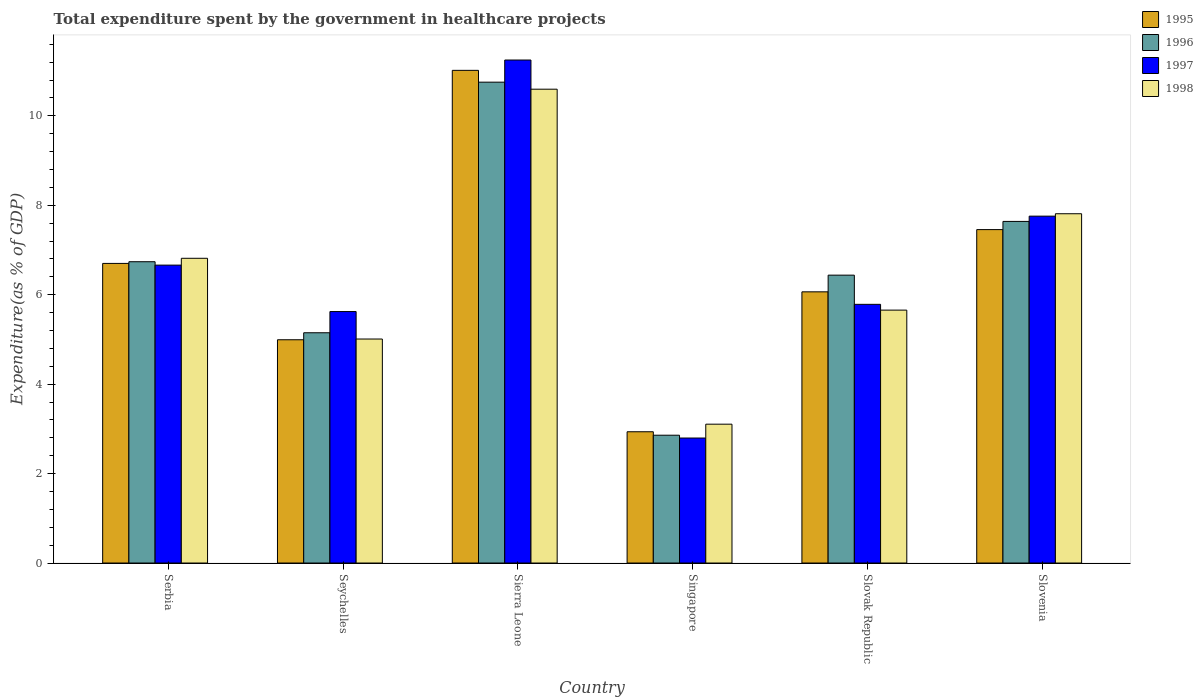How many different coloured bars are there?
Ensure brevity in your answer.  4. How many groups of bars are there?
Ensure brevity in your answer.  6. Are the number of bars on each tick of the X-axis equal?
Your answer should be very brief. Yes. How many bars are there on the 3rd tick from the left?
Offer a terse response. 4. How many bars are there on the 5th tick from the right?
Provide a succinct answer. 4. What is the label of the 4th group of bars from the left?
Your answer should be very brief. Singapore. In how many cases, is the number of bars for a given country not equal to the number of legend labels?
Your answer should be compact. 0. What is the total expenditure spent by the government in healthcare projects in 1997 in Slovenia?
Offer a very short reply. 7.76. Across all countries, what is the maximum total expenditure spent by the government in healthcare projects in 1998?
Provide a short and direct response. 10.59. Across all countries, what is the minimum total expenditure spent by the government in healthcare projects in 1998?
Your answer should be very brief. 3.1. In which country was the total expenditure spent by the government in healthcare projects in 1997 maximum?
Provide a succinct answer. Sierra Leone. In which country was the total expenditure spent by the government in healthcare projects in 1997 minimum?
Ensure brevity in your answer.  Singapore. What is the total total expenditure spent by the government in healthcare projects in 1998 in the graph?
Your answer should be very brief. 38.99. What is the difference between the total expenditure spent by the government in healthcare projects in 1997 in Serbia and that in Slovenia?
Give a very brief answer. -1.09. What is the difference between the total expenditure spent by the government in healthcare projects in 1996 in Sierra Leone and the total expenditure spent by the government in healthcare projects in 1997 in Slovak Republic?
Keep it short and to the point. 4.97. What is the average total expenditure spent by the government in healthcare projects in 1998 per country?
Ensure brevity in your answer.  6.5. What is the difference between the total expenditure spent by the government in healthcare projects of/in 1995 and total expenditure spent by the government in healthcare projects of/in 1997 in Serbia?
Offer a very short reply. 0.04. In how many countries, is the total expenditure spent by the government in healthcare projects in 1996 greater than 8.8 %?
Offer a terse response. 1. What is the ratio of the total expenditure spent by the government in healthcare projects in 1997 in Seychelles to that in Slovak Republic?
Keep it short and to the point. 0.97. What is the difference between the highest and the second highest total expenditure spent by the government in healthcare projects in 1996?
Your answer should be compact. 4.02. What is the difference between the highest and the lowest total expenditure spent by the government in healthcare projects in 1995?
Offer a very short reply. 8.08. In how many countries, is the total expenditure spent by the government in healthcare projects in 1995 greater than the average total expenditure spent by the government in healthcare projects in 1995 taken over all countries?
Your answer should be compact. 3. Is the sum of the total expenditure spent by the government in healthcare projects in 1998 in Seychelles and Slovenia greater than the maximum total expenditure spent by the government in healthcare projects in 1995 across all countries?
Offer a terse response. Yes. Is it the case that in every country, the sum of the total expenditure spent by the government in healthcare projects in 1998 and total expenditure spent by the government in healthcare projects in 1995 is greater than the sum of total expenditure spent by the government in healthcare projects in 1997 and total expenditure spent by the government in healthcare projects in 1996?
Offer a very short reply. No. How many bars are there?
Offer a terse response. 24. Does the graph contain any zero values?
Your answer should be compact. No. Does the graph contain grids?
Your answer should be compact. No. Where does the legend appear in the graph?
Offer a very short reply. Top right. How many legend labels are there?
Ensure brevity in your answer.  4. How are the legend labels stacked?
Provide a succinct answer. Vertical. What is the title of the graph?
Give a very brief answer. Total expenditure spent by the government in healthcare projects. Does "1961" appear as one of the legend labels in the graph?
Your answer should be very brief. No. What is the label or title of the X-axis?
Offer a very short reply. Country. What is the label or title of the Y-axis?
Provide a short and direct response. Expenditure(as % of GDP). What is the Expenditure(as % of GDP) in 1995 in Serbia?
Offer a terse response. 6.7. What is the Expenditure(as % of GDP) of 1996 in Serbia?
Keep it short and to the point. 6.74. What is the Expenditure(as % of GDP) of 1997 in Serbia?
Provide a short and direct response. 6.66. What is the Expenditure(as % of GDP) in 1998 in Serbia?
Give a very brief answer. 6.81. What is the Expenditure(as % of GDP) in 1995 in Seychelles?
Make the answer very short. 4.99. What is the Expenditure(as % of GDP) in 1996 in Seychelles?
Provide a succinct answer. 5.15. What is the Expenditure(as % of GDP) of 1997 in Seychelles?
Your response must be concise. 5.62. What is the Expenditure(as % of GDP) of 1998 in Seychelles?
Offer a terse response. 5.01. What is the Expenditure(as % of GDP) of 1995 in Sierra Leone?
Provide a short and direct response. 11.02. What is the Expenditure(as % of GDP) in 1996 in Sierra Leone?
Provide a short and direct response. 10.75. What is the Expenditure(as % of GDP) of 1997 in Sierra Leone?
Ensure brevity in your answer.  11.25. What is the Expenditure(as % of GDP) in 1998 in Sierra Leone?
Offer a very short reply. 10.59. What is the Expenditure(as % of GDP) of 1995 in Singapore?
Your answer should be compact. 2.94. What is the Expenditure(as % of GDP) in 1996 in Singapore?
Make the answer very short. 2.86. What is the Expenditure(as % of GDP) of 1997 in Singapore?
Provide a short and direct response. 2.8. What is the Expenditure(as % of GDP) of 1998 in Singapore?
Give a very brief answer. 3.1. What is the Expenditure(as % of GDP) of 1995 in Slovak Republic?
Your response must be concise. 6.06. What is the Expenditure(as % of GDP) in 1996 in Slovak Republic?
Your answer should be compact. 6.44. What is the Expenditure(as % of GDP) in 1997 in Slovak Republic?
Provide a succinct answer. 5.78. What is the Expenditure(as % of GDP) in 1998 in Slovak Republic?
Provide a succinct answer. 5.66. What is the Expenditure(as % of GDP) in 1995 in Slovenia?
Provide a succinct answer. 7.46. What is the Expenditure(as % of GDP) of 1996 in Slovenia?
Provide a succinct answer. 7.64. What is the Expenditure(as % of GDP) in 1997 in Slovenia?
Make the answer very short. 7.76. What is the Expenditure(as % of GDP) in 1998 in Slovenia?
Provide a succinct answer. 7.81. Across all countries, what is the maximum Expenditure(as % of GDP) of 1995?
Provide a short and direct response. 11.02. Across all countries, what is the maximum Expenditure(as % of GDP) in 1996?
Ensure brevity in your answer.  10.75. Across all countries, what is the maximum Expenditure(as % of GDP) of 1997?
Your answer should be very brief. 11.25. Across all countries, what is the maximum Expenditure(as % of GDP) of 1998?
Your answer should be very brief. 10.59. Across all countries, what is the minimum Expenditure(as % of GDP) of 1995?
Provide a short and direct response. 2.94. Across all countries, what is the minimum Expenditure(as % of GDP) in 1996?
Ensure brevity in your answer.  2.86. Across all countries, what is the minimum Expenditure(as % of GDP) in 1997?
Ensure brevity in your answer.  2.8. Across all countries, what is the minimum Expenditure(as % of GDP) in 1998?
Offer a very short reply. 3.1. What is the total Expenditure(as % of GDP) in 1995 in the graph?
Your answer should be compact. 39.16. What is the total Expenditure(as % of GDP) in 1996 in the graph?
Make the answer very short. 39.57. What is the total Expenditure(as % of GDP) in 1997 in the graph?
Provide a succinct answer. 39.87. What is the total Expenditure(as % of GDP) of 1998 in the graph?
Your answer should be very brief. 38.99. What is the difference between the Expenditure(as % of GDP) of 1995 in Serbia and that in Seychelles?
Ensure brevity in your answer.  1.71. What is the difference between the Expenditure(as % of GDP) in 1996 in Serbia and that in Seychelles?
Your answer should be compact. 1.59. What is the difference between the Expenditure(as % of GDP) of 1997 in Serbia and that in Seychelles?
Make the answer very short. 1.04. What is the difference between the Expenditure(as % of GDP) of 1998 in Serbia and that in Seychelles?
Your response must be concise. 1.81. What is the difference between the Expenditure(as % of GDP) in 1995 in Serbia and that in Sierra Leone?
Your answer should be compact. -4.32. What is the difference between the Expenditure(as % of GDP) in 1996 in Serbia and that in Sierra Leone?
Provide a succinct answer. -4.02. What is the difference between the Expenditure(as % of GDP) of 1997 in Serbia and that in Sierra Leone?
Ensure brevity in your answer.  -4.59. What is the difference between the Expenditure(as % of GDP) in 1998 in Serbia and that in Sierra Leone?
Your answer should be compact. -3.78. What is the difference between the Expenditure(as % of GDP) of 1995 in Serbia and that in Singapore?
Provide a short and direct response. 3.76. What is the difference between the Expenditure(as % of GDP) of 1996 in Serbia and that in Singapore?
Ensure brevity in your answer.  3.88. What is the difference between the Expenditure(as % of GDP) in 1997 in Serbia and that in Singapore?
Provide a succinct answer. 3.87. What is the difference between the Expenditure(as % of GDP) in 1998 in Serbia and that in Singapore?
Provide a succinct answer. 3.71. What is the difference between the Expenditure(as % of GDP) of 1995 in Serbia and that in Slovak Republic?
Keep it short and to the point. 0.64. What is the difference between the Expenditure(as % of GDP) in 1996 in Serbia and that in Slovak Republic?
Your response must be concise. 0.3. What is the difference between the Expenditure(as % of GDP) of 1997 in Serbia and that in Slovak Republic?
Your answer should be very brief. 0.88. What is the difference between the Expenditure(as % of GDP) of 1998 in Serbia and that in Slovak Republic?
Give a very brief answer. 1.16. What is the difference between the Expenditure(as % of GDP) of 1995 in Serbia and that in Slovenia?
Provide a short and direct response. -0.76. What is the difference between the Expenditure(as % of GDP) in 1996 in Serbia and that in Slovenia?
Make the answer very short. -0.9. What is the difference between the Expenditure(as % of GDP) in 1997 in Serbia and that in Slovenia?
Your answer should be very brief. -1.09. What is the difference between the Expenditure(as % of GDP) in 1998 in Serbia and that in Slovenia?
Offer a very short reply. -1. What is the difference between the Expenditure(as % of GDP) in 1995 in Seychelles and that in Sierra Leone?
Keep it short and to the point. -6.02. What is the difference between the Expenditure(as % of GDP) in 1996 in Seychelles and that in Sierra Leone?
Make the answer very short. -5.6. What is the difference between the Expenditure(as % of GDP) in 1997 in Seychelles and that in Sierra Leone?
Offer a very short reply. -5.62. What is the difference between the Expenditure(as % of GDP) of 1998 in Seychelles and that in Sierra Leone?
Your answer should be very brief. -5.59. What is the difference between the Expenditure(as % of GDP) in 1995 in Seychelles and that in Singapore?
Offer a very short reply. 2.06. What is the difference between the Expenditure(as % of GDP) in 1996 in Seychelles and that in Singapore?
Make the answer very short. 2.29. What is the difference between the Expenditure(as % of GDP) in 1997 in Seychelles and that in Singapore?
Your answer should be compact. 2.83. What is the difference between the Expenditure(as % of GDP) in 1998 in Seychelles and that in Singapore?
Your answer should be compact. 1.9. What is the difference between the Expenditure(as % of GDP) of 1995 in Seychelles and that in Slovak Republic?
Offer a terse response. -1.07. What is the difference between the Expenditure(as % of GDP) in 1996 in Seychelles and that in Slovak Republic?
Provide a short and direct response. -1.29. What is the difference between the Expenditure(as % of GDP) in 1997 in Seychelles and that in Slovak Republic?
Ensure brevity in your answer.  -0.16. What is the difference between the Expenditure(as % of GDP) of 1998 in Seychelles and that in Slovak Republic?
Your response must be concise. -0.65. What is the difference between the Expenditure(as % of GDP) in 1995 in Seychelles and that in Slovenia?
Offer a terse response. -2.46. What is the difference between the Expenditure(as % of GDP) of 1996 in Seychelles and that in Slovenia?
Give a very brief answer. -2.49. What is the difference between the Expenditure(as % of GDP) of 1997 in Seychelles and that in Slovenia?
Offer a terse response. -2.13. What is the difference between the Expenditure(as % of GDP) of 1998 in Seychelles and that in Slovenia?
Make the answer very short. -2.8. What is the difference between the Expenditure(as % of GDP) in 1995 in Sierra Leone and that in Singapore?
Your answer should be compact. 8.08. What is the difference between the Expenditure(as % of GDP) of 1996 in Sierra Leone and that in Singapore?
Provide a short and direct response. 7.89. What is the difference between the Expenditure(as % of GDP) in 1997 in Sierra Leone and that in Singapore?
Give a very brief answer. 8.45. What is the difference between the Expenditure(as % of GDP) in 1998 in Sierra Leone and that in Singapore?
Your answer should be compact. 7.49. What is the difference between the Expenditure(as % of GDP) of 1995 in Sierra Leone and that in Slovak Republic?
Provide a succinct answer. 4.95. What is the difference between the Expenditure(as % of GDP) in 1996 in Sierra Leone and that in Slovak Republic?
Your answer should be compact. 4.32. What is the difference between the Expenditure(as % of GDP) of 1997 in Sierra Leone and that in Slovak Republic?
Make the answer very short. 5.46. What is the difference between the Expenditure(as % of GDP) of 1998 in Sierra Leone and that in Slovak Republic?
Ensure brevity in your answer.  4.94. What is the difference between the Expenditure(as % of GDP) of 1995 in Sierra Leone and that in Slovenia?
Your answer should be very brief. 3.56. What is the difference between the Expenditure(as % of GDP) of 1996 in Sierra Leone and that in Slovenia?
Your response must be concise. 3.11. What is the difference between the Expenditure(as % of GDP) of 1997 in Sierra Leone and that in Slovenia?
Your response must be concise. 3.49. What is the difference between the Expenditure(as % of GDP) in 1998 in Sierra Leone and that in Slovenia?
Ensure brevity in your answer.  2.78. What is the difference between the Expenditure(as % of GDP) in 1995 in Singapore and that in Slovak Republic?
Offer a very short reply. -3.13. What is the difference between the Expenditure(as % of GDP) of 1996 in Singapore and that in Slovak Republic?
Give a very brief answer. -3.58. What is the difference between the Expenditure(as % of GDP) of 1997 in Singapore and that in Slovak Republic?
Offer a terse response. -2.99. What is the difference between the Expenditure(as % of GDP) of 1998 in Singapore and that in Slovak Republic?
Offer a terse response. -2.55. What is the difference between the Expenditure(as % of GDP) of 1995 in Singapore and that in Slovenia?
Your answer should be very brief. -4.52. What is the difference between the Expenditure(as % of GDP) in 1996 in Singapore and that in Slovenia?
Ensure brevity in your answer.  -4.78. What is the difference between the Expenditure(as % of GDP) of 1997 in Singapore and that in Slovenia?
Keep it short and to the point. -4.96. What is the difference between the Expenditure(as % of GDP) in 1998 in Singapore and that in Slovenia?
Offer a very short reply. -4.71. What is the difference between the Expenditure(as % of GDP) in 1995 in Slovak Republic and that in Slovenia?
Provide a short and direct response. -1.39. What is the difference between the Expenditure(as % of GDP) of 1996 in Slovak Republic and that in Slovenia?
Provide a succinct answer. -1.2. What is the difference between the Expenditure(as % of GDP) in 1997 in Slovak Republic and that in Slovenia?
Your answer should be compact. -1.97. What is the difference between the Expenditure(as % of GDP) in 1998 in Slovak Republic and that in Slovenia?
Give a very brief answer. -2.15. What is the difference between the Expenditure(as % of GDP) of 1995 in Serbia and the Expenditure(as % of GDP) of 1996 in Seychelles?
Your answer should be very brief. 1.55. What is the difference between the Expenditure(as % of GDP) in 1995 in Serbia and the Expenditure(as % of GDP) in 1997 in Seychelles?
Provide a short and direct response. 1.08. What is the difference between the Expenditure(as % of GDP) of 1995 in Serbia and the Expenditure(as % of GDP) of 1998 in Seychelles?
Offer a very short reply. 1.69. What is the difference between the Expenditure(as % of GDP) of 1996 in Serbia and the Expenditure(as % of GDP) of 1997 in Seychelles?
Your response must be concise. 1.11. What is the difference between the Expenditure(as % of GDP) of 1996 in Serbia and the Expenditure(as % of GDP) of 1998 in Seychelles?
Your answer should be compact. 1.73. What is the difference between the Expenditure(as % of GDP) in 1997 in Serbia and the Expenditure(as % of GDP) in 1998 in Seychelles?
Make the answer very short. 1.65. What is the difference between the Expenditure(as % of GDP) of 1995 in Serbia and the Expenditure(as % of GDP) of 1996 in Sierra Leone?
Ensure brevity in your answer.  -4.05. What is the difference between the Expenditure(as % of GDP) of 1995 in Serbia and the Expenditure(as % of GDP) of 1997 in Sierra Leone?
Offer a terse response. -4.55. What is the difference between the Expenditure(as % of GDP) in 1995 in Serbia and the Expenditure(as % of GDP) in 1998 in Sierra Leone?
Provide a succinct answer. -3.9. What is the difference between the Expenditure(as % of GDP) in 1996 in Serbia and the Expenditure(as % of GDP) in 1997 in Sierra Leone?
Offer a terse response. -4.51. What is the difference between the Expenditure(as % of GDP) in 1996 in Serbia and the Expenditure(as % of GDP) in 1998 in Sierra Leone?
Give a very brief answer. -3.86. What is the difference between the Expenditure(as % of GDP) in 1997 in Serbia and the Expenditure(as % of GDP) in 1998 in Sierra Leone?
Your answer should be compact. -3.93. What is the difference between the Expenditure(as % of GDP) in 1995 in Serbia and the Expenditure(as % of GDP) in 1996 in Singapore?
Offer a very short reply. 3.84. What is the difference between the Expenditure(as % of GDP) in 1995 in Serbia and the Expenditure(as % of GDP) in 1997 in Singapore?
Your answer should be compact. 3.9. What is the difference between the Expenditure(as % of GDP) of 1995 in Serbia and the Expenditure(as % of GDP) of 1998 in Singapore?
Ensure brevity in your answer.  3.59. What is the difference between the Expenditure(as % of GDP) of 1996 in Serbia and the Expenditure(as % of GDP) of 1997 in Singapore?
Offer a very short reply. 3.94. What is the difference between the Expenditure(as % of GDP) of 1996 in Serbia and the Expenditure(as % of GDP) of 1998 in Singapore?
Keep it short and to the point. 3.63. What is the difference between the Expenditure(as % of GDP) in 1997 in Serbia and the Expenditure(as % of GDP) in 1998 in Singapore?
Your answer should be compact. 3.56. What is the difference between the Expenditure(as % of GDP) of 1995 in Serbia and the Expenditure(as % of GDP) of 1996 in Slovak Republic?
Ensure brevity in your answer.  0.26. What is the difference between the Expenditure(as % of GDP) of 1995 in Serbia and the Expenditure(as % of GDP) of 1997 in Slovak Republic?
Offer a terse response. 0.92. What is the difference between the Expenditure(as % of GDP) of 1995 in Serbia and the Expenditure(as % of GDP) of 1998 in Slovak Republic?
Keep it short and to the point. 1.04. What is the difference between the Expenditure(as % of GDP) of 1996 in Serbia and the Expenditure(as % of GDP) of 1997 in Slovak Republic?
Make the answer very short. 0.95. What is the difference between the Expenditure(as % of GDP) of 1996 in Serbia and the Expenditure(as % of GDP) of 1998 in Slovak Republic?
Give a very brief answer. 1.08. What is the difference between the Expenditure(as % of GDP) of 1997 in Serbia and the Expenditure(as % of GDP) of 1998 in Slovak Republic?
Offer a very short reply. 1.01. What is the difference between the Expenditure(as % of GDP) of 1995 in Serbia and the Expenditure(as % of GDP) of 1996 in Slovenia?
Make the answer very short. -0.94. What is the difference between the Expenditure(as % of GDP) in 1995 in Serbia and the Expenditure(as % of GDP) in 1997 in Slovenia?
Make the answer very short. -1.06. What is the difference between the Expenditure(as % of GDP) in 1995 in Serbia and the Expenditure(as % of GDP) in 1998 in Slovenia?
Offer a very short reply. -1.11. What is the difference between the Expenditure(as % of GDP) in 1996 in Serbia and the Expenditure(as % of GDP) in 1997 in Slovenia?
Your answer should be compact. -1.02. What is the difference between the Expenditure(as % of GDP) in 1996 in Serbia and the Expenditure(as % of GDP) in 1998 in Slovenia?
Your answer should be very brief. -1.07. What is the difference between the Expenditure(as % of GDP) in 1997 in Serbia and the Expenditure(as % of GDP) in 1998 in Slovenia?
Provide a succinct answer. -1.15. What is the difference between the Expenditure(as % of GDP) in 1995 in Seychelles and the Expenditure(as % of GDP) in 1996 in Sierra Leone?
Your answer should be very brief. -5.76. What is the difference between the Expenditure(as % of GDP) of 1995 in Seychelles and the Expenditure(as % of GDP) of 1997 in Sierra Leone?
Your answer should be very brief. -6.25. What is the difference between the Expenditure(as % of GDP) in 1995 in Seychelles and the Expenditure(as % of GDP) in 1998 in Sierra Leone?
Give a very brief answer. -5.6. What is the difference between the Expenditure(as % of GDP) in 1996 in Seychelles and the Expenditure(as % of GDP) in 1997 in Sierra Leone?
Offer a terse response. -6.1. What is the difference between the Expenditure(as % of GDP) in 1996 in Seychelles and the Expenditure(as % of GDP) in 1998 in Sierra Leone?
Give a very brief answer. -5.45. What is the difference between the Expenditure(as % of GDP) in 1997 in Seychelles and the Expenditure(as % of GDP) in 1998 in Sierra Leone?
Keep it short and to the point. -4.97. What is the difference between the Expenditure(as % of GDP) of 1995 in Seychelles and the Expenditure(as % of GDP) of 1996 in Singapore?
Your answer should be very brief. 2.13. What is the difference between the Expenditure(as % of GDP) of 1995 in Seychelles and the Expenditure(as % of GDP) of 1997 in Singapore?
Make the answer very short. 2.2. What is the difference between the Expenditure(as % of GDP) of 1995 in Seychelles and the Expenditure(as % of GDP) of 1998 in Singapore?
Offer a very short reply. 1.89. What is the difference between the Expenditure(as % of GDP) of 1996 in Seychelles and the Expenditure(as % of GDP) of 1997 in Singapore?
Give a very brief answer. 2.35. What is the difference between the Expenditure(as % of GDP) of 1996 in Seychelles and the Expenditure(as % of GDP) of 1998 in Singapore?
Make the answer very short. 2.04. What is the difference between the Expenditure(as % of GDP) in 1997 in Seychelles and the Expenditure(as % of GDP) in 1998 in Singapore?
Provide a succinct answer. 2.52. What is the difference between the Expenditure(as % of GDP) in 1995 in Seychelles and the Expenditure(as % of GDP) in 1996 in Slovak Republic?
Your answer should be compact. -1.44. What is the difference between the Expenditure(as % of GDP) of 1995 in Seychelles and the Expenditure(as % of GDP) of 1997 in Slovak Republic?
Offer a very short reply. -0.79. What is the difference between the Expenditure(as % of GDP) in 1995 in Seychelles and the Expenditure(as % of GDP) in 1998 in Slovak Republic?
Make the answer very short. -0.66. What is the difference between the Expenditure(as % of GDP) in 1996 in Seychelles and the Expenditure(as % of GDP) in 1997 in Slovak Republic?
Keep it short and to the point. -0.64. What is the difference between the Expenditure(as % of GDP) of 1996 in Seychelles and the Expenditure(as % of GDP) of 1998 in Slovak Republic?
Provide a succinct answer. -0.51. What is the difference between the Expenditure(as % of GDP) of 1997 in Seychelles and the Expenditure(as % of GDP) of 1998 in Slovak Republic?
Your answer should be compact. -0.03. What is the difference between the Expenditure(as % of GDP) in 1995 in Seychelles and the Expenditure(as % of GDP) in 1996 in Slovenia?
Provide a short and direct response. -2.65. What is the difference between the Expenditure(as % of GDP) in 1995 in Seychelles and the Expenditure(as % of GDP) in 1997 in Slovenia?
Give a very brief answer. -2.76. What is the difference between the Expenditure(as % of GDP) in 1995 in Seychelles and the Expenditure(as % of GDP) in 1998 in Slovenia?
Give a very brief answer. -2.82. What is the difference between the Expenditure(as % of GDP) of 1996 in Seychelles and the Expenditure(as % of GDP) of 1997 in Slovenia?
Provide a succinct answer. -2.61. What is the difference between the Expenditure(as % of GDP) of 1996 in Seychelles and the Expenditure(as % of GDP) of 1998 in Slovenia?
Make the answer very short. -2.66. What is the difference between the Expenditure(as % of GDP) of 1997 in Seychelles and the Expenditure(as % of GDP) of 1998 in Slovenia?
Your response must be concise. -2.19. What is the difference between the Expenditure(as % of GDP) in 1995 in Sierra Leone and the Expenditure(as % of GDP) in 1996 in Singapore?
Your answer should be compact. 8.16. What is the difference between the Expenditure(as % of GDP) in 1995 in Sierra Leone and the Expenditure(as % of GDP) in 1997 in Singapore?
Keep it short and to the point. 8.22. What is the difference between the Expenditure(as % of GDP) of 1995 in Sierra Leone and the Expenditure(as % of GDP) of 1998 in Singapore?
Give a very brief answer. 7.91. What is the difference between the Expenditure(as % of GDP) in 1996 in Sierra Leone and the Expenditure(as % of GDP) in 1997 in Singapore?
Provide a short and direct response. 7.96. What is the difference between the Expenditure(as % of GDP) in 1996 in Sierra Leone and the Expenditure(as % of GDP) in 1998 in Singapore?
Your answer should be very brief. 7.65. What is the difference between the Expenditure(as % of GDP) in 1997 in Sierra Leone and the Expenditure(as % of GDP) in 1998 in Singapore?
Your response must be concise. 8.14. What is the difference between the Expenditure(as % of GDP) in 1995 in Sierra Leone and the Expenditure(as % of GDP) in 1996 in Slovak Republic?
Your answer should be compact. 4.58. What is the difference between the Expenditure(as % of GDP) of 1995 in Sierra Leone and the Expenditure(as % of GDP) of 1997 in Slovak Republic?
Your response must be concise. 5.23. What is the difference between the Expenditure(as % of GDP) of 1995 in Sierra Leone and the Expenditure(as % of GDP) of 1998 in Slovak Republic?
Provide a short and direct response. 5.36. What is the difference between the Expenditure(as % of GDP) of 1996 in Sierra Leone and the Expenditure(as % of GDP) of 1997 in Slovak Republic?
Your answer should be very brief. 4.97. What is the difference between the Expenditure(as % of GDP) in 1996 in Sierra Leone and the Expenditure(as % of GDP) in 1998 in Slovak Republic?
Provide a succinct answer. 5.1. What is the difference between the Expenditure(as % of GDP) in 1997 in Sierra Leone and the Expenditure(as % of GDP) in 1998 in Slovak Republic?
Ensure brevity in your answer.  5.59. What is the difference between the Expenditure(as % of GDP) of 1995 in Sierra Leone and the Expenditure(as % of GDP) of 1996 in Slovenia?
Offer a terse response. 3.38. What is the difference between the Expenditure(as % of GDP) of 1995 in Sierra Leone and the Expenditure(as % of GDP) of 1997 in Slovenia?
Ensure brevity in your answer.  3.26. What is the difference between the Expenditure(as % of GDP) in 1995 in Sierra Leone and the Expenditure(as % of GDP) in 1998 in Slovenia?
Provide a short and direct response. 3.21. What is the difference between the Expenditure(as % of GDP) in 1996 in Sierra Leone and the Expenditure(as % of GDP) in 1997 in Slovenia?
Make the answer very short. 3. What is the difference between the Expenditure(as % of GDP) of 1996 in Sierra Leone and the Expenditure(as % of GDP) of 1998 in Slovenia?
Your response must be concise. 2.94. What is the difference between the Expenditure(as % of GDP) in 1997 in Sierra Leone and the Expenditure(as % of GDP) in 1998 in Slovenia?
Your answer should be very brief. 3.44. What is the difference between the Expenditure(as % of GDP) in 1995 in Singapore and the Expenditure(as % of GDP) in 1996 in Slovak Republic?
Keep it short and to the point. -3.5. What is the difference between the Expenditure(as % of GDP) of 1995 in Singapore and the Expenditure(as % of GDP) of 1997 in Slovak Republic?
Provide a short and direct response. -2.85. What is the difference between the Expenditure(as % of GDP) of 1995 in Singapore and the Expenditure(as % of GDP) of 1998 in Slovak Republic?
Provide a succinct answer. -2.72. What is the difference between the Expenditure(as % of GDP) in 1996 in Singapore and the Expenditure(as % of GDP) in 1997 in Slovak Republic?
Keep it short and to the point. -2.93. What is the difference between the Expenditure(as % of GDP) of 1996 in Singapore and the Expenditure(as % of GDP) of 1998 in Slovak Republic?
Give a very brief answer. -2.8. What is the difference between the Expenditure(as % of GDP) of 1997 in Singapore and the Expenditure(as % of GDP) of 1998 in Slovak Republic?
Your answer should be compact. -2.86. What is the difference between the Expenditure(as % of GDP) of 1995 in Singapore and the Expenditure(as % of GDP) of 1996 in Slovenia?
Offer a terse response. -4.7. What is the difference between the Expenditure(as % of GDP) in 1995 in Singapore and the Expenditure(as % of GDP) in 1997 in Slovenia?
Offer a very short reply. -4.82. What is the difference between the Expenditure(as % of GDP) in 1995 in Singapore and the Expenditure(as % of GDP) in 1998 in Slovenia?
Your answer should be very brief. -4.87. What is the difference between the Expenditure(as % of GDP) in 1996 in Singapore and the Expenditure(as % of GDP) in 1997 in Slovenia?
Provide a succinct answer. -4.9. What is the difference between the Expenditure(as % of GDP) in 1996 in Singapore and the Expenditure(as % of GDP) in 1998 in Slovenia?
Give a very brief answer. -4.95. What is the difference between the Expenditure(as % of GDP) in 1997 in Singapore and the Expenditure(as % of GDP) in 1998 in Slovenia?
Your answer should be compact. -5.01. What is the difference between the Expenditure(as % of GDP) in 1995 in Slovak Republic and the Expenditure(as % of GDP) in 1996 in Slovenia?
Your response must be concise. -1.57. What is the difference between the Expenditure(as % of GDP) in 1995 in Slovak Republic and the Expenditure(as % of GDP) in 1997 in Slovenia?
Keep it short and to the point. -1.69. What is the difference between the Expenditure(as % of GDP) in 1995 in Slovak Republic and the Expenditure(as % of GDP) in 1998 in Slovenia?
Provide a short and direct response. -1.75. What is the difference between the Expenditure(as % of GDP) in 1996 in Slovak Republic and the Expenditure(as % of GDP) in 1997 in Slovenia?
Your answer should be compact. -1.32. What is the difference between the Expenditure(as % of GDP) in 1996 in Slovak Republic and the Expenditure(as % of GDP) in 1998 in Slovenia?
Offer a terse response. -1.37. What is the difference between the Expenditure(as % of GDP) of 1997 in Slovak Republic and the Expenditure(as % of GDP) of 1998 in Slovenia?
Keep it short and to the point. -2.03. What is the average Expenditure(as % of GDP) in 1995 per country?
Provide a succinct answer. 6.53. What is the average Expenditure(as % of GDP) in 1996 per country?
Provide a short and direct response. 6.6. What is the average Expenditure(as % of GDP) in 1997 per country?
Provide a succinct answer. 6.64. What is the average Expenditure(as % of GDP) in 1998 per country?
Make the answer very short. 6.5. What is the difference between the Expenditure(as % of GDP) in 1995 and Expenditure(as % of GDP) in 1996 in Serbia?
Your answer should be very brief. -0.04. What is the difference between the Expenditure(as % of GDP) in 1995 and Expenditure(as % of GDP) in 1997 in Serbia?
Offer a very short reply. 0.04. What is the difference between the Expenditure(as % of GDP) of 1995 and Expenditure(as % of GDP) of 1998 in Serbia?
Offer a terse response. -0.11. What is the difference between the Expenditure(as % of GDP) of 1996 and Expenditure(as % of GDP) of 1997 in Serbia?
Your answer should be very brief. 0.08. What is the difference between the Expenditure(as % of GDP) in 1996 and Expenditure(as % of GDP) in 1998 in Serbia?
Provide a short and direct response. -0.08. What is the difference between the Expenditure(as % of GDP) of 1997 and Expenditure(as % of GDP) of 1998 in Serbia?
Your answer should be very brief. -0.15. What is the difference between the Expenditure(as % of GDP) in 1995 and Expenditure(as % of GDP) in 1996 in Seychelles?
Your response must be concise. -0.16. What is the difference between the Expenditure(as % of GDP) in 1995 and Expenditure(as % of GDP) in 1997 in Seychelles?
Offer a very short reply. -0.63. What is the difference between the Expenditure(as % of GDP) of 1995 and Expenditure(as % of GDP) of 1998 in Seychelles?
Offer a very short reply. -0.02. What is the difference between the Expenditure(as % of GDP) of 1996 and Expenditure(as % of GDP) of 1997 in Seychelles?
Your answer should be very brief. -0.47. What is the difference between the Expenditure(as % of GDP) of 1996 and Expenditure(as % of GDP) of 1998 in Seychelles?
Ensure brevity in your answer.  0.14. What is the difference between the Expenditure(as % of GDP) in 1997 and Expenditure(as % of GDP) in 1998 in Seychelles?
Your answer should be very brief. 0.61. What is the difference between the Expenditure(as % of GDP) in 1995 and Expenditure(as % of GDP) in 1996 in Sierra Leone?
Offer a very short reply. 0.26. What is the difference between the Expenditure(as % of GDP) in 1995 and Expenditure(as % of GDP) in 1997 in Sierra Leone?
Keep it short and to the point. -0.23. What is the difference between the Expenditure(as % of GDP) of 1995 and Expenditure(as % of GDP) of 1998 in Sierra Leone?
Make the answer very short. 0.42. What is the difference between the Expenditure(as % of GDP) of 1996 and Expenditure(as % of GDP) of 1997 in Sierra Leone?
Offer a terse response. -0.49. What is the difference between the Expenditure(as % of GDP) in 1996 and Expenditure(as % of GDP) in 1998 in Sierra Leone?
Your response must be concise. 0.16. What is the difference between the Expenditure(as % of GDP) in 1997 and Expenditure(as % of GDP) in 1998 in Sierra Leone?
Provide a succinct answer. 0.65. What is the difference between the Expenditure(as % of GDP) of 1995 and Expenditure(as % of GDP) of 1996 in Singapore?
Your answer should be very brief. 0.08. What is the difference between the Expenditure(as % of GDP) in 1995 and Expenditure(as % of GDP) in 1997 in Singapore?
Make the answer very short. 0.14. What is the difference between the Expenditure(as % of GDP) in 1995 and Expenditure(as % of GDP) in 1998 in Singapore?
Offer a very short reply. -0.17. What is the difference between the Expenditure(as % of GDP) in 1996 and Expenditure(as % of GDP) in 1997 in Singapore?
Provide a succinct answer. 0.06. What is the difference between the Expenditure(as % of GDP) in 1996 and Expenditure(as % of GDP) in 1998 in Singapore?
Your answer should be very brief. -0.25. What is the difference between the Expenditure(as % of GDP) in 1997 and Expenditure(as % of GDP) in 1998 in Singapore?
Give a very brief answer. -0.31. What is the difference between the Expenditure(as % of GDP) in 1995 and Expenditure(as % of GDP) in 1996 in Slovak Republic?
Offer a very short reply. -0.37. What is the difference between the Expenditure(as % of GDP) in 1995 and Expenditure(as % of GDP) in 1997 in Slovak Republic?
Give a very brief answer. 0.28. What is the difference between the Expenditure(as % of GDP) of 1995 and Expenditure(as % of GDP) of 1998 in Slovak Republic?
Give a very brief answer. 0.41. What is the difference between the Expenditure(as % of GDP) of 1996 and Expenditure(as % of GDP) of 1997 in Slovak Republic?
Provide a succinct answer. 0.65. What is the difference between the Expenditure(as % of GDP) in 1996 and Expenditure(as % of GDP) in 1998 in Slovak Republic?
Your answer should be very brief. 0.78. What is the difference between the Expenditure(as % of GDP) of 1997 and Expenditure(as % of GDP) of 1998 in Slovak Republic?
Provide a short and direct response. 0.13. What is the difference between the Expenditure(as % of GDP) in 1995 and Expenditure(as % of GDP) in 1996 in Slovenia?
Keep it short and to the point. -0.18. What is the difference between the Expenditure(as % of GDP) in 1995 and Expenditure(as % of GDP) in 1997 in Slovenia?
Keep it short and to the point. -0.3. What is the difference between the Expenditure(as % of GDP) of 1995 and Expenditure(as % of GDP) of 1998 in Slovenia?
Offer a terse response. -0.35. What is the difference between the Expenditure(as % of GDP) of 1996 and Expenditure(as % of GDP) of 1997 in Slovenia?
Your response must be concise. -0.12. What is the difference between the Expenditure(as % of GDP) of 1996 and Expenditure(as % of GDP) of 1998 in Slovenia?
Provide a succinct answer. -0.17. What is the difference between the Expenditure(as % of GDP) of 1997 and Expenditure(as % of GDP) of 1998 in Slovenia?
Offer a terse response. -0.05. What is the ratio of the Expenditure(as % of GDP) in 1995 in Serbia to that in Seychelles?
Give a very brief answer. 1.34. What is the ratio of the Expenditure(as % of GDP) of 1996 in Serbia to that in Seychelles?
Provide a short and direct response. 1.31. What is the ratio of the Expenditure(as % of GDP) in 1997 in Serbia to that in Seychelles?
Your response must be concise. 1.18. What is the ratio of the Expenditure(as % of GDP) in 1998 in Serbia to that in Seychelles?
Provide a short and direct response. 1.36. What is the ratio of the Expenditure(as % of GDP) in 1995 in Serbia to that in Sierra Leone?
Make the answer very short. 0.61. What is the ratio of the Expenditure(as % of GDP) of 1996 in Serbia to that in Sierra Leone?
Offer a terse response. 0.63. What is the ratio of the Expenditure(as % of GDP) in 1997 in Serbia to that in Sierra Leone?
Give a very brief answer. 0.59. What is the ratio of the Expenditure(as % of GDP) of 1998 in Serbia to that in Sierra Leone?
Keep it short and to the point. 0.64. What is the ratio of the Expenditure(as % of GDP) in 1995 in Serbia to that in Singapore?
Your answer should be compact. 2.28. What is the ratio of the Expenditure(as % of GDP) in 1996 in Serbia to that in Singapore?
Offer a very short reply. 2.36. What is the ratio of the Expenditure(as % of GDP) in 1997 in Serbia to that in Singapore?
Provide a short and direct response. 2.38. What is the ratio of the Expenditure(as % of GDP) in 1998 in Serbia to that in Singapore?
Give a very brief answer. 2.19. What is the ratio of the Expenditure(as % of GDP) of 1995 in Serbia to that in Slovak Republic?
Offer a very short reply. 1.1. What is the ratio of the Expenditure(as % of GDP) of 1996 in Serbia to that in Slovak Republic?
Make the answer very short. 1.05. What is the ratio of the Expenditure(as % of GDP) in 1997 in Serbia to that in Slovak Republic?
Your answer should be very brief. 1.15. What is the ratio of the Expenditure(as % of GDP) of 1998 in Serbia to that in Slovak Republic?
Give a very brief answer. 1.2. What is the ratio of the Expenditure(as % of GDP) of 1995 in Serbia to that in Slovenia?
Make the answer very short. 0.9. What is the ratio of the Expenditure(as % of GDP) of 1996 in Serbia to that in Slovenia?
Make the answer very short. 0.88. What is the ratio of the Expenditure(as % of GDP) in 1997 in Serbia to that in Slovenia?
Make the answer very short. 0.86. What is the ratio of the Expenditure(as % of GDP) in 1998 in Serbia to that in Slovenia?
Provide a short and direct response. 0.87. What is the ratio of the Expenditure(as % of GDP) in 1995 in Seychelles to that in Sierra Leone?
Ensure brevity in your answer.  0.45. What is the ratio of the Expenditure(as % of GDP) of 1996 in Seychelles to that in Sierra Leone?
Provide a succinct answer. 0.48. What is the ratio of the Expenditure(as % of GDP) in 1997 in Seychelles to that in Sierra Leone?
Ensure brevity in your answer.  0.5. What is the ratio of the Expenditure(as % of GDP) of 1998 in Seychelles to that in Sierra Leone?
Provide a short and direct response. 0.47. What is the ratio of the Expenditure(as % of GDP) in 1995 in Seychelles to that in Singapore?
Provide a succinct answer. 1.7. What is the ratio of the Expenditure(as % of GDP) in 1996 in Seychelles to that in Singapore?
Keep it short and to the point. 1.8. What is the ratio of the Expenditure(as % of GDP) in 1997 in Seychelles to that in Singapore?
Ensure brevity in your answer.  2.01. What is the ratio of the Expenditure(as % of GDP) of 1998 in Seychelles to that in Singapore?
Offer a very short reply. 1.61. What is the ratio of the Expenditure(as % of GDP) of 1995 in Seychelles to that in Slovak Republic?
Your response must be concise. 0.82. What is the ratio of the Expenditure(as % of GDP) in 1996 in Seychelles to that in Slovak Republic?
Your answer should be compact. 0.8. What is the ratio of the Expenditure(as % of GDP) in 1997 in Seychelles to that in Slovak Republic?
Your answer should be very brief. 0.97. What is the ratio of the Expenditure(as % of GDP) in 1998 in Seychelles to that in Slovak Republic?
Provide a succinct answer. 0.89. What is the ratio of the Expenditure(as % of GDP) of 1995 in Seychelles to that in Slovenia?
Your answer should be very brief. 0.67. What is the ratio of the Expenditure(as % of GDP) of 1996 in Seychelles to that in Slovenia?
Offer a very short reply. 0.67. What is the ratio of the Expenditure(as % of GDP) in 1997 in Seychelles to that in Slovenia?
Offer a terse response. 0.72. What is the ratio of the Expenditure(as % of GDP) of 1998 in Seychelles to that in Slovenia?
Make the answer very short. 0.64. What is the ratio of the Expenditure(as % of GDP) in 1995 in Sierra Leone to that in Singapore?
Offer a very short reply. 3.75. What is the ratio of the Expenditure(as % of GDP) of 1996 in Sierra Leone to that in Singapore?
Keep it short and to the point. 3.76. What is the ratio of the Expenditure(as % of GDP) in 1997 in Sierra Leone to that in Singapore?
Make the answer very short. 4.02. What is the ratio of the Expenditure(as % of GDP) of 1998 in Sierra Leone to that in Singapore?
Ensure brevity in your answer.  3.41. What is the ratio of the Expenditure(as % of GDP) in 1995 in Sierra Leone to that in Slovak Republic?
Your answer should be very brief. 1.82. What is the ratio of the Expenditure(as % of GDP) of 1996 in Sierra Leone to that in Slovak Republic?
Give a very brief answer. 1.67. What is the ratio of the Expenditure(as % of GDP) of 1997 in Sierra Leone to that in Slovak Republic?
Your answer should be compact. 1.94. What is the ratio of the Expenditure(as % of GDP) of 1998 in Sierra Leone to that in Slovak Republic?
Your answer should be very brief. 1.87. What is the ratio of the Expenditure(as % of GDP) in 1995 in Sierra Leone to that in Slovenia?
Your answer should be very brief. 1.48. What is the ratio of the Expenditure(as % of GDP) in 1996 in Sierra Leone to that in Slovenia?
Offer a terse response. 1.41. What is the ratio of the Expenditure(as % of GDP) in 1997 in Sierra Leone to that in Slovenia?
Your response must be concise. 1.45. What is the ratio of the Expenditure(as % of GDP) of 1998 in Sierra Leone to that in Slovenia?
Keep it short and to the point. 1.36. What is the ratio of the Expenditure(as % of GDP) in 1995 in Singapore to that in Slovak Republic?
Your response must be concise. 0.48. What is the ratio of the Expenditure(as % of GDP) in 1996 in Singapore to that in Slovak Republic?
Make the answer very short. 0.44. What is the ratio of the Expenditure(as % of GDP) of 1997 in Singapore to that in Slovak Republic?
Provide a succinct answer. 0.48. What is the ratio of the Expenditure(as % of GDP) in 1998 in Singapore to that in Slovak Republic?
Ensure brevity in your answer.  0.55. What is the ratio of the Expenditure(as % of GDP) in 1995 in Singapore to that in Slovenia?
Give a very brief answer. 0.39. What is the ratio of the Expenditure(as % of GDP) of 1996 in Singapore to that in Slovenia?
Your answer should be compact. 0.37. What is the ratio of the Expenditure(as % of GDP) in 1997 in Singapore to that in Slovenia?
Offer a terse response. 0.36. What is the ratio of the Expenditure(as % of GDP) of 1998 in Singapore to that in Slovenia?
Your response must be concise. 0.4. What is the ratio of the Expenditure(as % of GDP) of 1995 in Slovak Republic to that in Slovenia?
Your answer should be very brief. 0.81. What is the ratio of the Expenditure(as % of GDP) in 1996 in Slovak Republic to that in Slovenia?
Offer a terse response. 0.84. What is the ratio of the Expenditure(as % of GDP) of 1997 in Slovak Republic to that in Slovenia?
Provide a succinct answer. 0.75. What is the ratio of the Expenditure(as % of GDP) of 1998 in Slovak Republic to that in Slovenia?
Ensure brevity in your answer.  0.72. What is the difference between the highest and the second highest Expenditure(as % of GDP) in 1995?
Give a very brief answer. 3.56. What is the difference between the highest and the second highest Expenditure(as % of GDP) of 1996?
Provide a succinct answer. 3.11. What is the difference between the highest and the second highest Expenditure(as % of GDP) of 1997?
Make the answer very short. 3.49. What is the difference between the highest and the second highest Expenditure(as % of GDP) of 1998?
Your response must be concise. 2.78. What is the difference between the highest and the lowest Expenditure(as % of GDP) of 1995?
Offer a terse response. 8.08. What is the difference between the highest and the lowest Expenditure(as % of GDP) in 1996?
Your response must be concise. 7.89. What is the difference between the highest and the lowest Expenditure(as % of GDP) in 1997?
Ensure brevity in your answer.  8.45. What is the difference between the highest and the lowest Expenditure(as % of GDP) of 1998?
Ensure brevity in your answer.  7.49. 